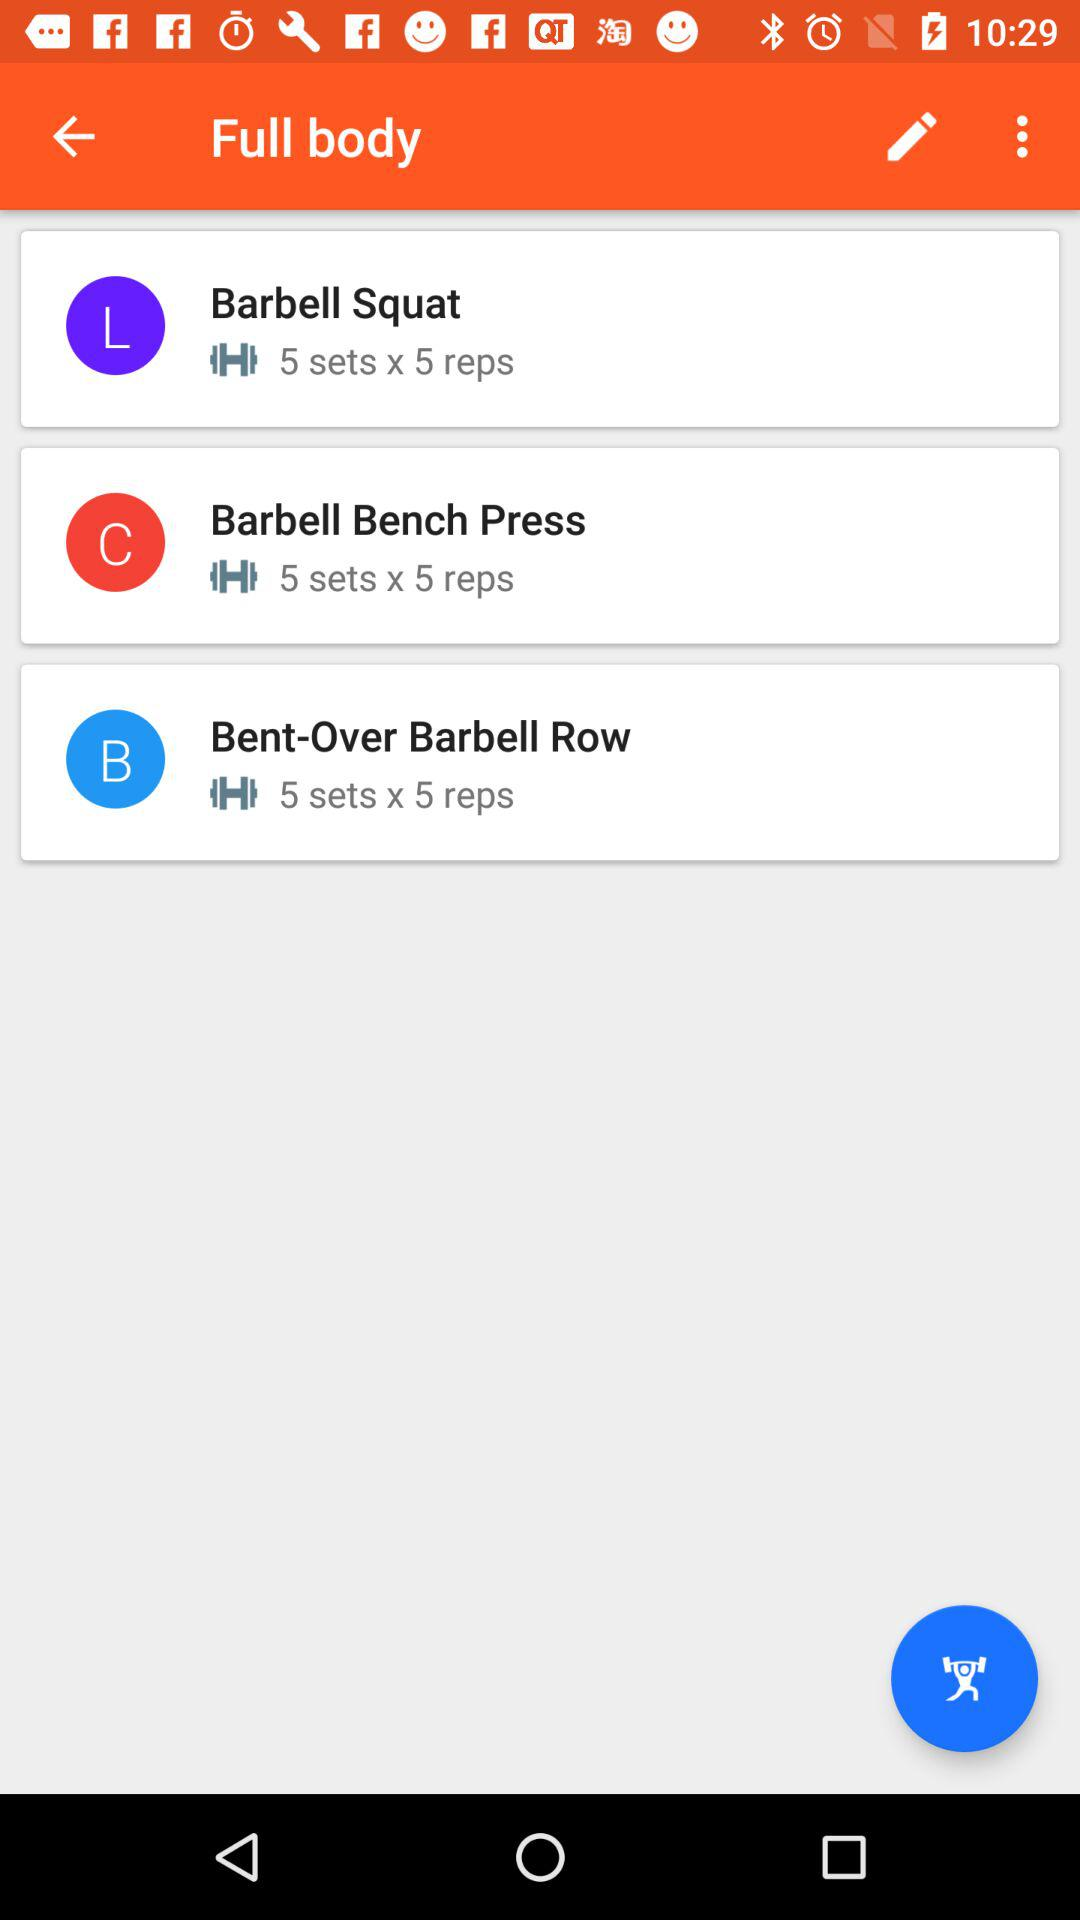How many sets is the exercise Barbell Squat performed for?
Answer the question using a single word or phrase. 5 